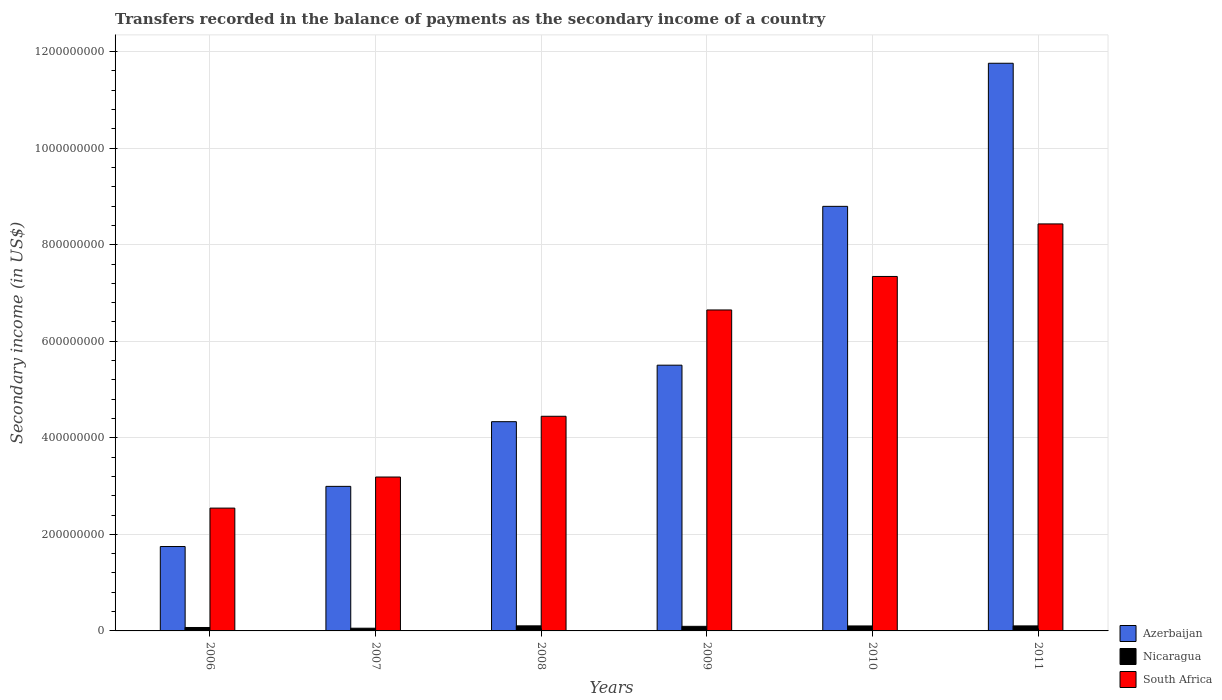How many different coloured bars are there?
Offer a very short reply. 3. How many groups of bars are there?
Provide a short and direct response. 6. Are the number of bars per tick equal to the number of legend labels?
Offer a very short reply. Yes. Are the number of bars on each tick of the X-axis equal?
Give a very brief answer. Yes. How many bars are there on the 5th tick from the right?
Your response must be concise. 3. What is the label of the 2nd group of bars from the left?
Keep it short and to the point. 2007. What is the secondary income of in Nicaragua in 2008?
Your response must be concise. 1.05e+07. Across all years, what is the maximum secondary income of in South Africa?
Provide a succinct answer. 8.43e+08. Across all years, what is the minimum secondary income of in Nicaragua?
Offer a terse response. 5.60e+06. In which year was the secondary income of in Azerbaijan maximum?
Your answer should be very brief. 2011. In which year was the secondary income of in Azerbaijan minimum?
Your answer should be compact. 2006. What is the total secondary income of in South Africa in the graph?
Ensure brevity in your answer.  3.26e+09. What is the difference between the secondary income of in Nicaragua in 2006 and that in 2007?
Your answer should be compact. 1.50e+06. What is the difference between the secondary income of in South Africa in 2011 and the secondary income of in Azerbaijan in 2009?
Give a very brief answer. 2.93e+08. What is the average secondary income of in Azerbaijan per year?
Ensure brevity in your answer.  5.86e+08. In the year 2008, what is the difference between the secondary income of in Azerbaijan and secondary income of in Nicaragua?
Give a very brief answer. 4.23e+08. In how many years, is the secondary income of in Azerbaijan greater than 920000000 US$?
Provide a short and direct response. 1. What is the ratio of the secondary income of in South Africa in 2006 to that in 2007?
Keep it short and to the point. 0.8. What is the difference between the highest and the second highest secondary income of in Azerbaijan?
Give a very brief answer. 2.96e+08. What is the difference between the highest and the lowest secondary income of in Nicaragua?
Your answer should be compact. 4.90e+06. Is the sum of the secondary income of in South Africa in 2006 and 2011 greater than the maximum secondary income of in Nicaragua across all years?
Your response must be concise. Yes. What does the 3rd bar from the left in 2010 represents?
Offer a terse response. South Africa. What does the 1st bar from the right in 2009 represents?
Provide a short and direct response. South Africa. How many bars are there?
Offer a terse response. 18. How many years are there in the graph?
Offer a very short reply. 6. Are the values on the major ticks of Y-axis written in scientific E-notation?
Your answer should be compact. No. Does the graph contain any zero values?
Offer a very short reply. No. Does the graph contain grids?
Your response must be concise. Yes. What is the title of the graph?
Provide a short and direct response. Transfers recorded in the balance of payments as the secondary income of a country. Does "Belarus" appear as one of the legend labels in the graph?
Offer a very short reply. No. What is the label or title of the X-axis?
Keep it short and to the point. Years. What is the label or title of the Y-axis?
Provide a succinct answer. Secondary income (in US$). What is the Secondary income (in US$) of Azerbaijan in 2006?
Give a very brief answer. 1.75e+08. What is the Secondary income (in US$) of Nicaragua in 2006?
Your response must be concise. 7.10e+06. What is the Secondary income (in US$) of South Africa in 2006?
Offer a terse response. 2.54e+08. What is the Secondary income (in US$) in Azerbaijan in 2007?
Ensure brevity in your answer.  2.99e+08. What is the Secondary income (in US$) in Nicaragua in 2007?
Your answer should be very brief. 5.60e+06. What is the Secondary income (in US$) in South Africa in 2007?
Your answer should be compact. 3.19e+08. What is the Secondary income (in US$) in Azerbaijan in 2008?
Provide a succinct answer. 4.33e+08. What is the Secondary income (in US$) in Nicaragua in 2008?
Make the answer very short. 1.05e+07. What is the Secondary income (in US$) in South Africa in 2008?
Offer a very short reply. 4.45e+08. What is the Secondary income (in US$) of Azerbaijan in 2009?
Ensure brevity in your answer.  5.50e+08. What is the Secondary income (in US$) of Nicaragua in 2009?
Provide a succinct answer. 9.50e+06. What is the Secondary income (in US$) of South Africa in 2009?
Your answer should be very brief. 6.65e+08. What is the Secondary income (in US$) of Azerbaijan in 2010?
Provide a succinct answer. 8.79e+08. What is the Secondary income (in US$) in Nicaragua in 2010?
Ensure brevity in your answer.  1.03e+07. What is the Secondary income (in US$) of South Africa in 2010?
Keep it short and to the point. 7.34e+08. What is the Secondary income (in US$) of Azerbaijan in 2011?
Make the answer very short. 1.18e+09. What is the Secondary income (in US$) of Nicaragua in 2011?
Ensure brevity in your answer.  1.04e+07. What is the Secondary income (in US$) in South Africa in 2011?
Offer a terse response. 8.43e+08. Across all years, what is the maximum Secondary income (in US$) in Azerbaijan?
Keep it short and to the point. 1.18e+09. Across all years, what is the maximum Secondary income (in US$) in Nicaragua?
Keep it short and to the point. 1.05e+07. Across all years, what is the maximum Secondary income (in US$) of South Africa?
Ensure brevity in your answer.  8.43e+08. Across all years, what is the minimum Secondary income (in US$) in Azerbaijan?
Provide a succinct answer. 1.75e+08. Across all years, what is the minimum Secondary income (in US$) in Nicaragua?
Your response must be concise. 5.60e+06. Across all years, what is the minimum Secondary income (in US$) in South Africa?
Offer a terse response. 2.54e+08. What is the total Secondary income (in US$) in Azerbaijan in the graph?
Your response must be concise. 3.51e+09. What is the total Secondary income (in US$) of Nicaragua in the graph?
Offer a very short reply. 5.34e+07. What is the total Secondary income (in US$) in South Africa in the graph?
Keep it short and to the point. 3.26e+09. What is the difference between the Secondary income (in US$) in Azerbaijan in 2006 and that in 2007?
Provide a short and direct response. -1.25e+08. What is the difference between the Secondary income (in US$) of Nicaragua in 2006 and that in 2007?
Your response must be concise. 1.50e+06. What is the difference between the Secondary income (in US$) of South Africa in 2006 and that in 2007?
Offer a very short reply. -6.44e+07. What is the difference between the Secondary income (in US$) in Azerbaijan in 2006 and that in 2008?
Ensure brevity in your answer.  -2.59e+08. What is the difference between the Secondary income (in US$) of Nicaragua in 2006 and that in 2008?
Provide a short and direct response. -3.40e+06. What is the difference between the Secondary income (in US$) of South Africa in 2006 and that in 2008?
Keep it short and to the point. -1.90e+08. What is the difference between the Secondary income (in US$) of Azerbaijan in 2006 and that in 2009?
Offer a very short reply. -3.76e+08. What is the difference between the Secondary income (in US$) of Nicaragua in 2006 and that in 2009?
Your answer should be very brief. -2.40e+06. What is the difference between the Secondary income (in US$) of South Africa in 2006 and that in 2009?
Ensure brevity in your answer.  -4.10e+08. What is the difference between the Secondary income (in US$) of Azerbaijan in 2006 and that in 2010?
Your response must be concise. -7.05e+08. What is the difference between the Secondary income (in US$) of Nicaragua in 2006 and that in 2010?
Offer a very short reply. -3.20e+06. What is the difference between the Secondary income (in US$) of South Africa in 2006 and that in 2010?
Keep it short and to the point. -4.80e+08. What is the difference between the Secondary income (in US$) of Azerbaijan in 2006 and that in 2011?
Your answer should be compact. -1.00e+09. What is the difference between the Secondary income (in US$) in Nicaragua in 2006 and that in 2011?
Give a very brief answer. -3.30e+06. What is the difference between the Secondary income (in US$) of South Africa in 2006 and that in 2011?
Offer a terse response. -5.89e+08. What is the difference between the Secondary income (in US$) of Azerbaijan in 2007 and that in 2008?
Give a very brief answer. -1.34e+08. What is the difference between the Secondary income (in US$) in Nicaragua in 2007 and that in 2008?
Provide a short and direct response. -4.90e+06. What is the difference between the Secondary income (in US$) of South Africa in 2007 and that in 2008?
Keep it short and to the point. -1.26e+08. What is the difference between the Secondary income (in US$) in Azerbaijan in 2007 and that in 2009?
Your answer should be compact. -2.51e+08. What is the difference between the Secondary income (in US$) of Nicaragua in 2007 and that in 2009?
Make the answer very short. -3.90e+06. What is the difference between the Secondary income (in US$) in South Africa in 2007 and that in 2009?
Offer a terse response. -3.46e+08. What is the difference between the Secondary income (in US$) of Azerbaijan in 2007 and that in 2010?
Your answer should be very brief. -5.80e+08. What is the difference between the Secondary income (in US$) of Nicaragua in 2007 and that in 2010?
Provide a short and direct response. -4.70e+06. What is the difference between the Secondary income (in US$) of South Africa in 2007 and that in 2010?
Offer a very short reply. -4.15e+08. What is the difference between the Secondary income (in US$) of Azerbaijan in 2007 and that in 2011?
Your answer should be compact. -8.76e+08. What is the difference between the Secondary income (in US$) in Nicaragua in 2007 and that in 2011?
Make the answer very short. -4.80e+06. What is the difference between the Secondary income (in US$) of South Africa in 2007 and that in 2011?
Your answer should be very brief. -5.24e+08. What is the difference between the Secondary income (in US$) of Azerbaijan in 2008 and that in 2009?
Offer a terse response. -1.17e+08. What is the difference between the Secondary income (in US$) in South Africa in 2008 and that in 2009?
Your response must be concise. -2.20e+08. What is the difference between the Secondary income (in US$) of Azerbaijan in 2008 and that in 2010?
Keep it short and to the point. -4.46e+08. What is the difference between the Secondary income (in US$) in South Africa in 2008 and that in 2010?
Your answer should be compact. -2.90e+08. What is the difference between the Secondary income (in US$) of Azerbaijan in 2008 and that in 2011?
Provide a short and direct response. -7.42e+08. What is the difference between the Secondary income (in US$) of South Africa in 2008 and that in 2011?
Ensure brevity in your answer.  -3.98e+08. What is the difference between the Secondary income (in US$) in Azerbaijan in 2009 and that in 2010?
Provide a succinct answer. -3.29e+08. What is the difference between the Secondary income (in US$) of Nicaragua in 2009 and that in 2010?
Offer a terse response. -8.00e+05. What is the difference between the Secondary income (in US$) of South Africa in 2009 and that in 2010?
Your answer should be compact. -6.94e+07. What is the difference between the Secondary income (in US$) of Azerbaijan in 2009 and that in 2011?
Offer a very short reply. -6.25e+08. What is the difference between the Secondary income (in US$) in Nicaragua in 2009 and that in 2011?
Your answer should be compact. -9.00e+05. What is the difference between the Secondary income (in US$) of South Africa in 2009 and that in 2011?
Give a very brief answer. -1.78e+08. What is the difference between the Secondary income (in US$) of Azerbaijan in 2010 and that in 2011?
Ensure brevity in your answer.  -2.96e+08. What is the difference between the Secondary income (in US$) in South Africa in 2010 and that in 2011?
Provide a succinct answer. -1.09e+08. What is the difference between the Secondary income (in US$) in Azerbaijan in 2006 and the Secondary income (in US$) in Nicaragua in 2007?
Offer a very short reply. 1.69e+08. What is the difference between the Secondary income (in US$) of Azerbaijan in 2006 and the Secondary income (in US$) of South Africa in 2007?
Give a very brief answer. -1.44e+08. What is the difference between the Secondary income (in US$) in Nicaragua in 2006 and the Secondary income (in US$) in South Africa in 2007?
Provide a succinct answer. -3.12e+08. What is the difference between the Secondary income (in US$) in Azerbaijan in 2006 and the Secondary income (in US$) in Nicaragua in 2008?
Your response must be concise. 1.64e+08. What is the difference between the Secondary income (in US$) of Azerbaijan in 2006 and the Secondary income (in US$) of South Africa in 2008?
Your answer should be compact. -2.70e+08. What is the difference between the Secondary income (in US$) of Nicaragua in 2006 and the Secondary income (in US$) of South Africa in 2008?
Ensure brevity in your answer.  -4.38e+08. What is the difference between the Secondary income (in US$) of Azerbaijan in 2006 and the Secondary income (in US$) of Nicaragua in 2009?
Ensure brevity in your answer.  1.65e+08. What is the difference between the Secondary income (in US$) of Azerbaijan in 2006 and the Secondary income (in US$) of South Africa in 2009?
Offer a very short reply. -4.90e+08. What is the difference between the Secondary income (in US$) of Nicaragua in 2006 and the Secondary income (in US$) of South Africa in 2009?
Offer a very short reply. -6.58e+08. What is the difference between the Secondary income (in US$) in Azerbaijan in 2006 and the Secondary income (in US$) in Nicaragua in 2010?
Offer a terse response. 1.65e+08. What is the difference between the Secondary income (in US$) in Azerbaijan in 2006 and the Secondary income (in US$) in South Africa in 2010?
Provide a succinct answer. -5.59e+08. What is the difference between the Secondary income (in US$) of Nicaragua in 2006 and the Secondary income (in US$) of South Africa in 2010?
Ensure brevity in your answer.  -7.27e+08. What is the difference between the Secondary income (in US$) in Azerbaijan in 2006 and the Secondary income (in US$) in Nicaragua in 2011?
Your answer should be very brief. 1.64e+08. What is the difference between the Secondary income (in US$) in Azerbaijan in 2006 and the Secondary income (in US$) in South Africa in 2011?
Make the answer very short. -6.68e+08. What is the difference between the Secondary income (in US$) of Nicaragua in 2006 and the Secondary income (in US$) of South Africa in 2011?
Your answer should be very brief. -8.36e+08. What is the difference between the Secondary income (in US$) of Azerbaijan in 2007 and the Secondary income (in US$) of Nicaragua in 2008?
Keep it short and to the point. 2.89e+08. What is the difference between the Secondary income (in US$) of Azerbaijan in 2007 and the Secondary income (in US$) of South Africa in 2008?
Give a very brief answer. -1.45e+08. What is the difference between the Secondary income (in US$) in Nicaragua in 2007 and the Secondary income (in US$) in South Africa in 2008?
Your response must be concise. -4.39e+08. What is the difference between the Secondary income (in US$) in Azerbaijan in 2007 and the Secondary income (in US$) in Nicaragua in 2009?
Your response must be concise. 2.90e+08. What is the difference between the Secondary income (in US$) in Azerbaijan in 2007 and the Secondary income (in US$) in South Africa in 2009?
Keep it short and to the point. -3.65e+08. What is the difference between the Secondary income (in US$) in Nicaragua in 2007 and the Secondary income (in US$) in South Africa in 2009?
Offer a terse response. -6.59e+08. What is the difference between the Secondary income (in US$) in Azerbaijan in 2007 and the Secondary income (in US$) in Nicaragua in 2010?
Offer a very short reply. 2.89e+08. What is the difference between the Secondary income (in US$) in Azerbaijan in 2007 and the Secondary income (in US$) in South Africa in 2010?
Provide a short and direct response. -4.35e+08. What is the difference between the Secondary income (in US$) in Nicaragua in 2007 and the Secondary income (in US$) in South Africa in 2010?
Your answer should be very brief. -7.29e+08. What is the difference between the Secondary income (in US$) in Azerbaijan in 2007 and the Secondary income (in US$) in Nicaragua in 2011?
Your answer should be very brief. 2.89e+08. What is the difference between the Secondary income (in US$) in Azerbaijan in 2007 and the Secondary income (in US$) in South Africa in 2011?
Your answer should be very brief. -5.44e+08. What is the difference between the Secondary income (in US$) in Nicaragua in 2007 and the Secondary income (in US$) in South Africa in 2011?
Provide a succinct answer. -8.37e+08. What is the difference between the Secondary income (in US$) of Azerbaijan in 2008 and the Secondary income (in US$) of Nicaragua in 2009?
Your response must be concise. 4.24e+08. What is the difference between the Secondary income (in US$) of Azerbaijan in 2008 and the Secondary income (in US$) of South Africa in 2009?
Offer a terse response. -2.31e+08. What is the difference between the Secondary income (in US$) of Nicaragua in 2008 and the Secondary income (in US$) of South Africa in 2009?
Give a very brief answer. -6.54e+08. What is the difference between the Secondary income (in US$) of Azerbaijan in 2008 and the Secondary income (in US$) of Nicaragua in 2010?
Give a very brief answer. 4.23e+08. What is the difference between the Secondary income (in US$) of Azerbaijan in 2008 and the Secondary income (in US$) of South Africa in 2010?
Make the answer very short. -3.01e+08. What is the difference between the Secondary income (in US$) in Nicaragua in 2008 and the Secondary income (in US$) in South Africa in 2010?
Keep it short and to the point. -7.24e+08. What is the difference between the Secondary income (in US$) in Azerbaijan in 2008 and the Secondary income (in US$) in Nicaragua in 2011?
Your answer should be compact. 4.23e+08. What is the difference between the Secondary income (in US$) of Azerbaijan in 2008 and the Secondary income (in US$) of South Africa in 2011?
Provide a succinct answer. -4.10e+08. What is the difference between the Secondary income (in US$) in Nicaragua in 2008 and the Secondary income (in US$) in South Africa in 2011?
Keep it short and to the point. -8.33e+08. What is the difference between the Secondary income (in US$) of Azerbaijan in 2009 and the Secondary income (in US$) of Nicaragua in 2010?
Ensure brevity in your answer.  5.40e+08. What is the difference between the Secondary income (in US$) in Azerbaijan in 2009 and the Secondary income (in US$) in South Africa in 2010?
Give a very brief answer. -1.84e+08. What is the difference between the Secondary income (in US$) of Nicaragua in 2009 and the Secondary income (in US$) of South Africa in 2010?
Your answer should be compact. -7.25e+08. What is the difference between the Secondary income (in US$) in Azerbaijan in 2009 and the Secondary income (in US$) in Nicaragua in 2011?
Provide a short and direct response. 5.40e+08. What is the difference between the Secondary income (in US$) of Azerbaijan in 2009 and the Secondary income (in US$) of South Africa in 2011?
Ensure brevity in your answer.  -2.93e+08. What is the difference between the Secondary income (in US$) in Nicaragua in 2009 and the Secondary income (in US$) in South Africa in 2011?
Provide a succinct answer. -8.34e+08. What is the difference between the Secondary income (in US$) of Azerbaijan in 2010 and the Secondary income (in US$) of Nicaragua in 2011?
Make the answer very short. 8.69e+08. What is the difference between the Secondary income (in US$) in Azerbaijan in 2010 and the Secondary income (in US$) in South Africa in 2011?
Keep it short and to the point. 3.64e+07. What is the difference between the Secondary income (in US$) of Nicaragua in 2010 and the Secondary income (in US$) of South Africa in 2011?
Your answer should be compact. -8.33e+08. What is the average Secondary income (in US$) of Azerbaijan per year?
Give a very brief answer. 5.86e+08. What is the average Secondary income (in US$) of Nicaragua per year?
Keep it short and to the point. 8.90e+06. What is the average Secondary income (in US$) of South Africa per year?
Provide a short and direct response. 5.43e+08. In the year 2006, what is the difference between the Secondary income (in US$) of Azerbaijan and Secondary income (in US$) of Nicaragua?
Your response must be concise. 1.68e+08. In the year 2006, what is the difference between the Secondary income (in US$) in Azerbaijan and Secondary income (in US$) in South Africa?
Your answer should be very brief. -7.96e+07. In the year 2006, what is the difference between the Secondary income (in US$) of Nicaragua and Secondary income (in US$) of South Africa?
Offer a terse response. -2.47e+08. In the year 2007, what is the difference between the Secondary income (in US$) in Azerbaijan and Secondary income (in US$) in Nicaragua?
Offer a very short reply. 2.94e+08. In the year 2007, what is the difference between the Secondary income (in US$) in Azerbaijan and Secondary income (in US$) in South Africa?
Provide a short and direct response. -1.93e+07. In the year 2007, what is the difference between the Secondary income (in US$) of Nicaragua and Secondary income (in US$) of South Africa?
Keep it short and to the point. -3.13e+08. In the year 2008, what is the difference between the Secondary income (in US$) in Azerbaijan and Secondary income (in US$) in Nicaragua?
Provide a succinct answer. 4.23e+08. In the year 2008, what is the difference between the Secondary income (in US$) of Azerbaijan and Secondary income (in US$) of South Africa?
Ensure brevity in your answer.  -1.12e+07. In the year 2008, what is the difference between the Secondary income (in US$) of Nicaragua and Secondary income (in US$) of South Africa?
Give a very brief answer. -4.34e+08. In the year 2009, what is the difference between the Secondary income (in US$) of Azerbaijan and Secondary income (in US$) of Nicaragua?
Ensure brevity in your answer.  5.41e+08. In the year 2009, what is the difference between the Secondary income (in US$) in Azerbaijan and Secondary income (in US$) in South Africa?
Provide a short and direct response. -1.14e+08. In the year 2009, what is the difference between the Secondary income (in US$) of Nicaragua and Secondary income (in US$) of South Africa?
Your answer should be very brief. -6.55e+08. In the year 2010, what is the difference between the Secondary income (in US$) in Azerbaijan and Secondary income (in US$) in Nicaragua?
Offer a very short reply. 8.69e+08. In the year 2010, what is the difference between the Secondary income (in US$) of Azerbaijan and Secondary income (in US$) of South Africa?
Offer a very short reply. 1.45e+08. In the year 2010, what is the difference between the Secondary income (in US$) of Nicaragua and Secondary income (in US$) of South Africa?
Your response must be concise. -7.24e+08. In the year 2011, what is the difference between the Secondary income (in US$) of Azerbaijan and Secondary income (in US$) of Nicaragua?
Your response must be concise. 1.17e+09. In the year 2011, what is the difference between the Secondary income (in US$) of Azerbaijan and Secondary income (in US$) of South Africa?
Ensure brevity in your answer.  3.33e+08. In the year 2011, what is the difference between the Secondary income (in US$) in Nicaragua and Secondary income (in US$) in South Africa?
Provide a succinct answer. -8.33e+08. What is the ratio of the Secondary income (in US$) of Azerbaijan in 2006 to that in 2007?
Your answer should be compact. 0.58. What is the ratio of the Secondary income (in US$) of Nicaragua in 2006 to that in 2007?
Give a very brief answer. 1.27. What is the ratio of the Secondary income (in US$) in South Africa in 2006 to that in 2007?
Offer a very short reply. 0.8. What is the ratio of the Secondary income (in US$) of Azerbaijan in 2006 to that in 2008?
Your answer should be compact. 0.4. What is the ratio of the Secondary income (in US$) in Nicaragua in 2006 to that in 2008?
Your answer should be compact. 0.68. What is the ratio of the Secondary income (in US$) of South Africa in 2006 to that in 2008?
Provide a short and direct response. 0.57. What is the ratio of the Secondary income (in US$) of Azerbaijan in 2006 to that in 2009?
Offer a very short reply. 0.32. What is the ratio of the Secondary income (in US$) in Nicaragua in 2006 to that in 2009?
Offer a very short reply. 0.75. What is the ratio of the Secondary income (in US$) in South Africa in 2006 to that in 2009?
Provide a succinct answer. 0.38. What is the ratio of the Secondary income (in US$) of Azerbaijan in 2006 to that in 2010?
Ensure brevity in your answer.  0.2. What is the ratio of the Secondary income (in US$) of Nicaragua in 2006 to that in 2010?
Your answer should be compact. 0.69. What is the ratio of the Secondary income (in US$) of South Africa in 2006 to that in 2010?
Provide a short and direct response. 0.35. What is the ratio of the Secondary income (in US$) of Azerbaijan in 2006 to that in 2011?
Offer a terse response. 0.15. What is the ratio of the Secondary income (in US$) in Nicaragua in 2006 to that in 2011?
Your answer should be compact. 0.68. What is the ratio of the Secondary income (in US$) in South Africa in 2006 to that in 2011?
Your answer should be compact. 0.3. What is the ratio of the Secondary income (in US$) of Azerbaijan in 2007 to that in 2008?
Your answer should be very brief. 0.69. What is the ratio of the Secondary income (in US$) of Nicaragua in 2007 to that in 2008?
Offer a terse response. 0.53. What is the ratio of the Secondary income (in US$) in South Africa in 2007 to that in 2008?
Provide a short and direct response. 0.72. What is the ratio of the Secondary income (in US$) of Azerbaijan in 2007 to that in 2009?
Offer a very short reply. 0.54. What is the ratio of the Secondary income (in US$) in Nicaragua in 2007 to that in 2009?
Your answer should be compact. 0.59. What is the ratio of the Secondary income (in US$) in South Africa in 2007 to that in 2009?
Offer a very short reply. 0.48. What is the ratio of the Secondary income (in US$) in Azerbaijan in 2007 to that in 2010?
Ensure brevity in your answer.  0.34. What is the ratio of the Secondary income (in US$) in Nicaragua in 2007 to that in 2010?
Offer a terse response. 0.54. What is the ratio of the Secondary income (in US$) of South Africa in 2007 to that in 2010?
Your response must be concise. 0.43. What is the ratio of the Secondary income (in US$) of Azerbaijan in 2007 to that in 2011?
Your answer should be very brief. 0.25. What is the ratio of the Secondary income (in US$) of Nicaragua in 2007 to that in 2011?
Offer a terse response. 0.54. What is the ratio of the Secondary income (in US$) of South Africa in 2007 to that in 2011?
Give a very brief answer. 0.38. What is the ratio of the Secondary income (in US$) of Azerbaijan in 2008 to that in 2009?
Provide a short and direct response. 0.79. What is the ratio of the Secondary income (in US$) of Nicaragua in 2008 to that in 2009?
Your answer should be compact. 1.11. What is the ratio of the Secondary income (in US$) of South Africa in 2008 to that in 2009?
Make the answer very short. 0.67. What is the ratio of the Secondary income (in US$) of Azerbaijan in 2008 to that in 2010?
Keep it short and to the point. 0.49. What is the ratio of the Secondary income (in US$) in Nicaragua in 2008 to that in 2010?
Ensure brevity in your answer.  1.02. What is the ratio of the Secondary income (in US$) in South Africa in 2008 to that in 2010?
Your answer should be very brief. 0.61. What is the ratio of the Secondary income (in US$) in Azerbaijan in 2008 to that in 2011?
Make the answer very short. 0.37. What is the ratio of the Secondary income (in US$) of Nicaragua in 2008 to that in 2011?
Offer a terse response. 1.01. What is the ratio of the Secondary income (in US$) of South Africa in 2008 to that in 2011?
Offer a terse response. 0.53. What is the ratio of the Secondary income (in US$) of Azerbaijan in 2009 to that in 2010?
Offer a very short reply. 0.63. What is the ratio of the Secondary income (in US$) of Nicaragua in 2009 to that in 2010?
Offer a very short reply. 0.92. What is the ratio of the Secondary income (in US$) of South Africa in 2009 to that in 2010?
Make the answer very short. 0.91. What is the ratio of the Secondary income (in US$) in Azerbaijan in 2009 to that in 2011?
Your answer should be compact. 0.47. What is the ratio of the Secondary income (in US$) of Nicaragua in 2009 to that in 2011?
Your answer should be compact. 0.91. What is the ratio of the Secondary income (in US$) in South Africa in 2009 to that in 2011?
Provide a succinct answer. 0.79. What is the ratio of the Secondary income (in US$) of Azerbaijan in 2010 to that in 2011?
Give a very brief answer. 0.75. What is the ratio of the Secondary income (in US$) in Nicaragua in 2010 to that in 2011?
Your answer should be compact. 0.99. What is the ratio of the Secondary income (in US$) of South Africa in 2010 to that in 2011?
Your answer should be compact. 0.87. What is the difference between the highest and the second highest Secondary income (in US$) in Azerbaijan?
Give a very brief answer. 2.96e+08. What is the difference between the highest and the second highest Secondary income (in US$) of Nicaragua?
Your response must be concise. 1.00e+05. What is the difference between the highest and the second highest Secondary income (in US$) of South Africa?
Your answer should be compact. 1.09e+08. What is the difference between the highest and the lowest Secondary income (in US$) of Azerbaijan?
Ensure brevity in your answer.  1.00e+09. What is the difference between the highest and the lowest Secondary income (in US$) of Nicaragua?
Provide a succinct answer. 4.90e+06. What is the difference between the highest and the lowest Secondary income (in US$) of South Africa?
Your response must be concise. 5.89e+08. 